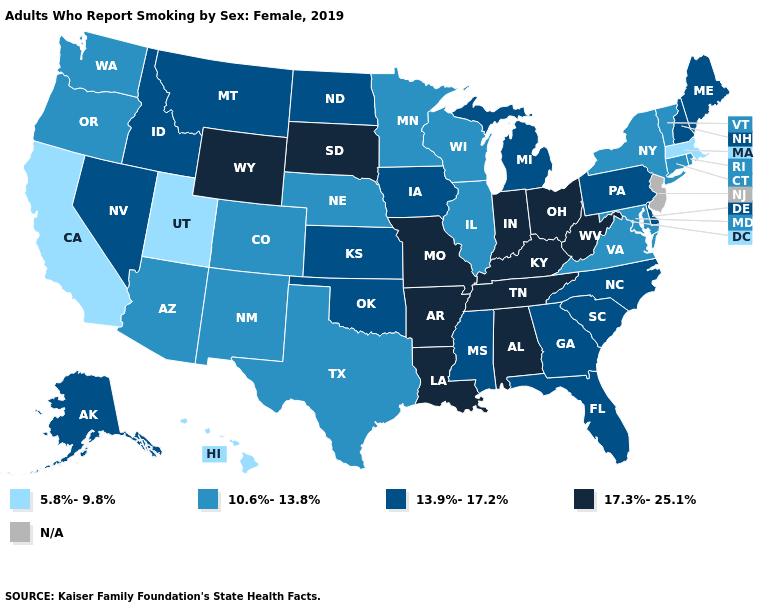Name the states that have a value in the range N/A?
Answer briefly. New Jersey. What is the value of North Carolina?
Answer briefly. 13.9%-17.2%. Name the states that have a value in the range N/A?
Short answer required. New Jersey. Name the states that have a value in the range 10.6%-13.8%?
Give a very brief answer. Arizona, Colorado, Connecticut, Illinois, Maryland, Minnesota, Nebraska, New Mexico, New York, Oregon, Rhode Island, Texas, Vermont, Virginia, Washington, Wisconsin. What is the highest value in the Northeast ?
Quick response, please. 13.9%-17.2%. Name the states that have a value in the range 17.3%-25.1%?
Answer briefly. Alabama, Arkansas, Indiana, Kentucky, Louisiana, Missouri, Ohio, South Dakota, Tennessee, West Virginia, Wyoming. What is the value of Michigan?
Give a very brief answer. 13.9%-17.2%. What is the lowest value in the Northeast?
Concise answer only. 5.8%-9.8%. Which states have the lowest value in the Northeast?
Give a very brief answer. Massachusetts. What is the value of Alaska?
Answer briefly. 13.9%-17.2%. Which states hav the highest value in the Northeast?
Give a very brief answer. Maine, New Hampshire, Pennsylvania. What is the lowest value in states that border Massachusetts?
Answer briefly. 10.6%-13.8%. Name the states that have a value in the range N/A?
Write a very short answer. New Jersey. Does the map have missing data?
Quick response, please. Yes. 